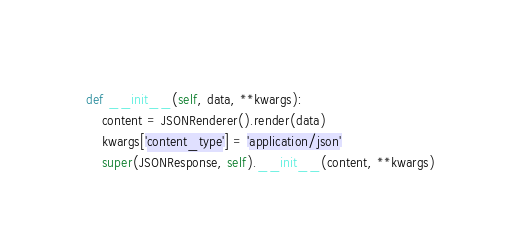<code> <loc_0><loc_0><loc_500><loc_500><_Python_>    
    def __init__(self, data, **kwargs):
        content = JSONRenderer().render(data)
        kwargs['content_type'] = 'application/json'
        super(JSONResponse, self).__init__(content, **kwargs)</code> 